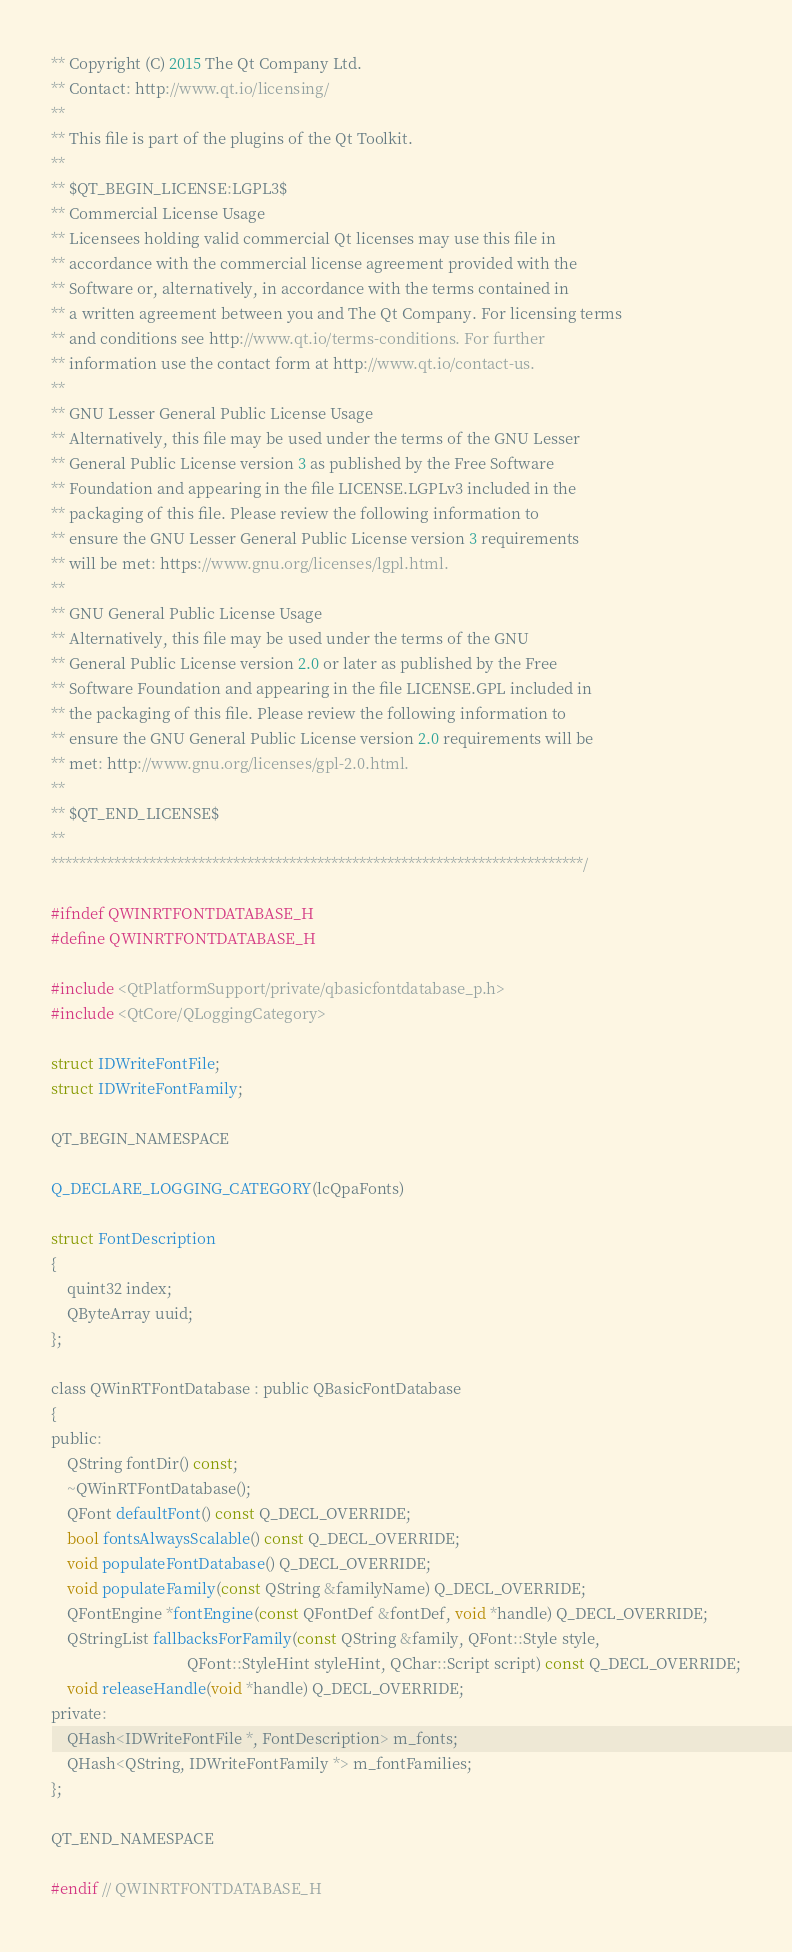<code> <loc_0><loc_0><loc_500><loc_500><_C_>** Copyright (C) 2015 The Qt Company Ltd.
** Contact: http://www.qt.io/licensing/
**
** This file is part of the plugins of the Qt Toolkit.
**
** $QT_BEGIN_LICENSE:LGPL3$
** Commercial License Usage
** Licensees holding valid commercial Qt licenses may use this file in
** accordance with the commercial license agreement provided with the
** Software or, alternatively, in accordance with the terms contained in
** a written agreement between you and The Qt Company. For licensing terms
** and conditions see http://www.qt.io/terms-conditions. For further
** information use the contact form at http://www.qt.io/contact-us.
**
** GNU Lesser General Public License Usage
** Alternatively, this file may be used under the terms of the GNU Lesser
** General Public License version 3 as published by the Free Software
** Foundation and appearing in the file LICENSE.LGPLv3 included in the
** packaging of this file. Please review the following information to
** ensure the GNU Lesser General Public License version 3 requirements
** will be met: https://www.gnu.org/licenses/lgpl.html.
**
** GNU General Public License Usage
** Alternatively, this file may be used under the terms of the GNU
** General Public License version 2.0 or later as published by the Free
** Software Foundation and appearing in the file LICENSE.GPL included in
** the packaging of this file. Please review the following information to
** ensure the GNU General Public License version 2.0 requirements will be
** met: http://www.gnu.org/licenses/gpl-2.0.html.
**
** $QT_END_LICENSE$
**
****************************************************************************/

#ifndef QWINRTFONTDATABASE_H
#define QWINRTFONTDATABASE_H

#include <QtPlatformSupport/private/qbasicfontdatabase_p.h>
#include <QtCore/QLoggingCategory>

struct IDWriteFontFile;
struct IDWriteFontFamily;

QT_BEGIN_NAMESPACE

Q_DECLARE_LOGGING_CATEGORY(lcQpaFonts)

struct FontDescription
{
    quint32 index;
    QByteArray uuid;
};

class QWinRTFontDatabase : public QBasicFontDatabase
{
public:
    QString fontDir() const;
    ~QWinRTFontDatabase();
    QFont defaultFont() const Q_DECL_OVERRIDE;
    bool fontsAlwaysScalable() const Q_DECL_OVERRIDE;
    void populateFontDatabase() Q_DECL_OVERRIDE;
    void populateFamily(const QString &familyName) Q_DECL_OVERRIDE;
    QFontEngine *fontEngine(const QFontDef &fontDef, void *handle) Q_DECL_OVERRIDE;
    QStringList fallbacksForFamily(const QString &family, QFont::Style style,
                                   QFont::StyleHint styleHint, QChar::Script script) const Q_DECL_OVERRIDE;
    void releaseHandle(void *handle) Q_DECL_OVERRIDE;
private:
    QHash<IDWriteFontFile *, FontDescription> m_fonts;
    QHash<QString, IDWriteFontFamily *> m_fontFamilies;
};

QT_END_NAMESPACE

#endif // QWINRTFONTDATABASE_H
</code> 